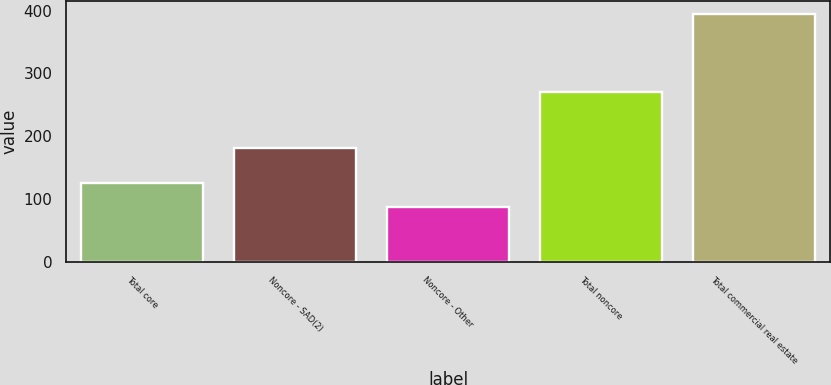Convert chart. <chart><loc_0><loc_0><loc_500><loc_500><bar_chart><fcel>Total core<fcel>Noncore - SAD(2)<fcel>Noncore - Other<fcel>Total noncore<fcel>Total commercial real estate<nl><fcel>125<fcel>182<fcel>88<fcel>270<fcel>395<nl></chart> 